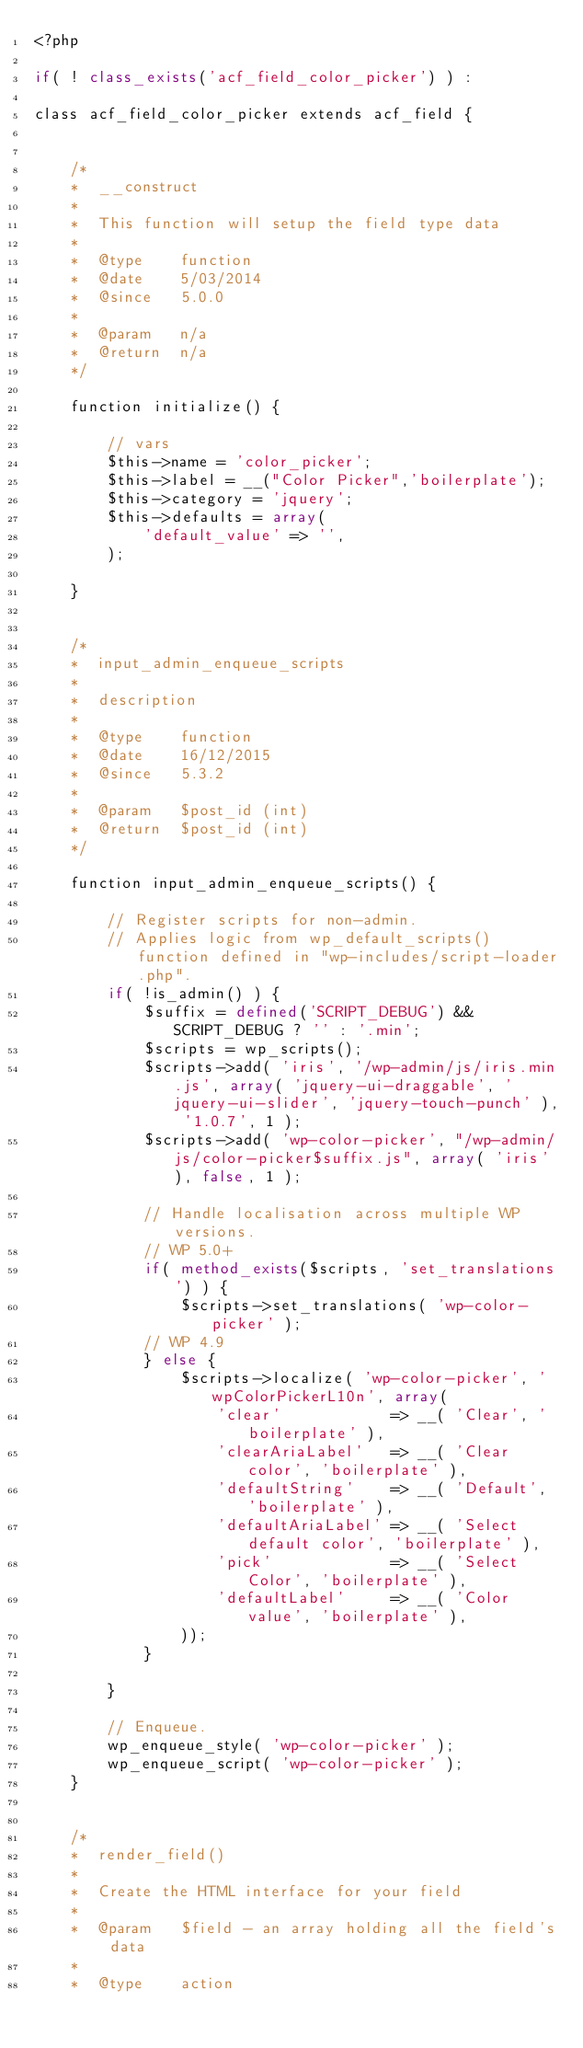Convert code to text. <code><loc_0><loc_0><loc_500><loc_500><_PHP_><?php

if( ! class_exists('acf_field_color_picker') ) :

class acf_field_color_picker extends acf_field {
	
	
	/*
	*  __construct
	*
	*  This function will setup the field type data
	*
	*  @type	function
	*  @date	5/03/2014
	*  @since	5.0.0
	*
	*  @param	n/a
	*  @return	n/a
	*/
	
	function initialize() {
		
		// vars
		$this->name = 'color_picker';
		$this->label = __("Color Picker",'boilerplate');
		$this->category = 'jquery';
		$this->defaults = array(
			'default_value'	=> '',
		);
		
	}
	
	
	/*
	*  input_admin_enqueue_scripts
	*
	*  description
	*
	*  @type	function
	*  @date	16/12/2015
	*  @since	5.3.2
	*
	*  @param	$post_id (int)
	*  @return	$post_id (int)
	*/
	
	function input_admin_enqueue_scripts() {

		// Register scripts for non-admin.
		// Applies logic from wp_default_scripts() function defined in "wp-includes/script-loader.php".
		if( !is_admin() ) {
			$suffix = defined('SCRIPT_DEBUG') && SCRIPT_DEBUG ? '' : '.min';
			$scripts = wp_scripts();
			$scripts->add( 'iris', '/wp-admin/js/iris.min.js', array( 'jquery-ui-draggable', 'jquery-ui-slider', 'jquery-touch-punch' ), '1.0.7', 1 );
			$scripts->add( 'wp-color-picker', "/wp-admin/js/color-picker$suffix.js", array( 'iris' ), false, 1 );
			
			// Handle localisation across multiple WP versions. 
			// WP 5.0+
			if( method_exists($scripts, 'set_translations') ) {
				$scripts->set_translations( 'wp-color-picker' );
			// WP 4.9
			} else {
				$scripts->localize( 'wp-color-picker', 'wpColorPickerL10n', array(
					'clear'            => __( 'Clear', 'boilerplate' ),
					'clearAriaLabel'   => __( 'Clear color', 'boilerplate' ),
					'defaultString'    => __( 'Default', 'boilerplate' ),
					'defaultAriaLabel' => __( 'Select default color', 'boilerplate' ),
					'pick'             => __( 'Select Color', 'boilerplate' ),
					'defaultLabel'     => __( 'Color value', 'boilerplate' ),
				));
			}
			
		}
		
		// Enqueue.
		wp_enqueue_style( 'wp-color-picker' );
		wp_enqueue_script( 'wp-color-picker' );			
	}
	
	
	/*
	*  render_field()
	*
	*  Create the HTML interface for your field
	*
	*  @param	$field - an array holding all the field's data
	*
	*  @type	action</code> 